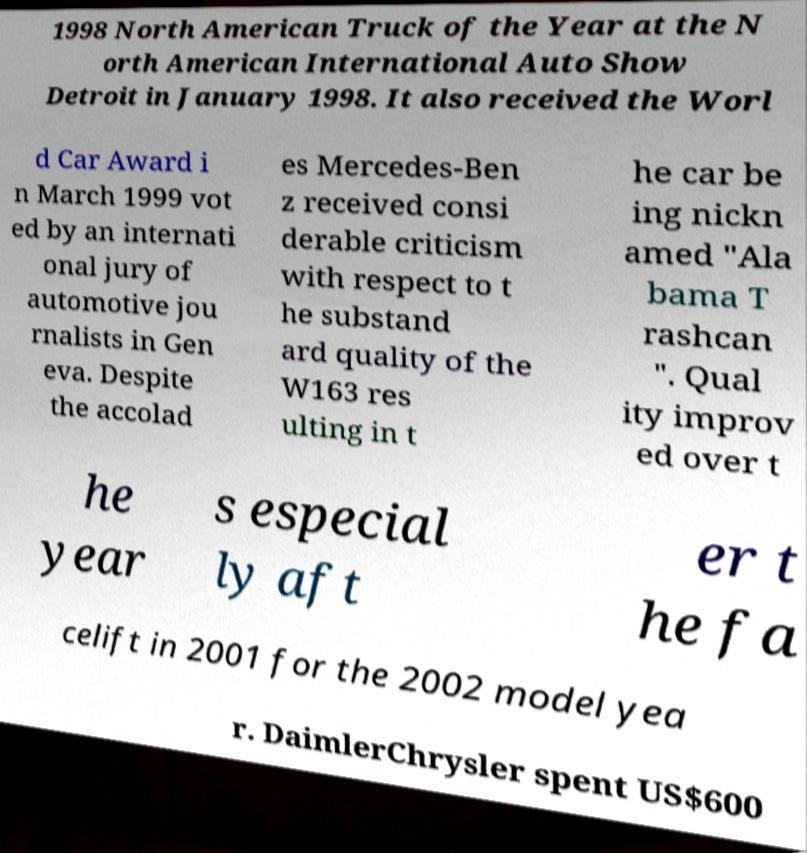Please read and relay the text visible in this image. What does it say? 1998 North American Truck of the Year at the N orth American International Auto Show Detroit in January 1998. It also received the Worl d Car Award i n March 1999 vot ed by an internati onal jury of automotive jou rnalists in Gen eva. Despite the accolad es Mercedes-Ben z received consi derable criticism with respect to t he substand ard quality of the W163 res ulting in t he car be ing nickn amed "Ala bama T rashcan ". Qual ity improv ed over t he year s especial ly aft er t he fa celift in 2001 for the 2002 model yea r. DaimlerChrysler spent US$600 